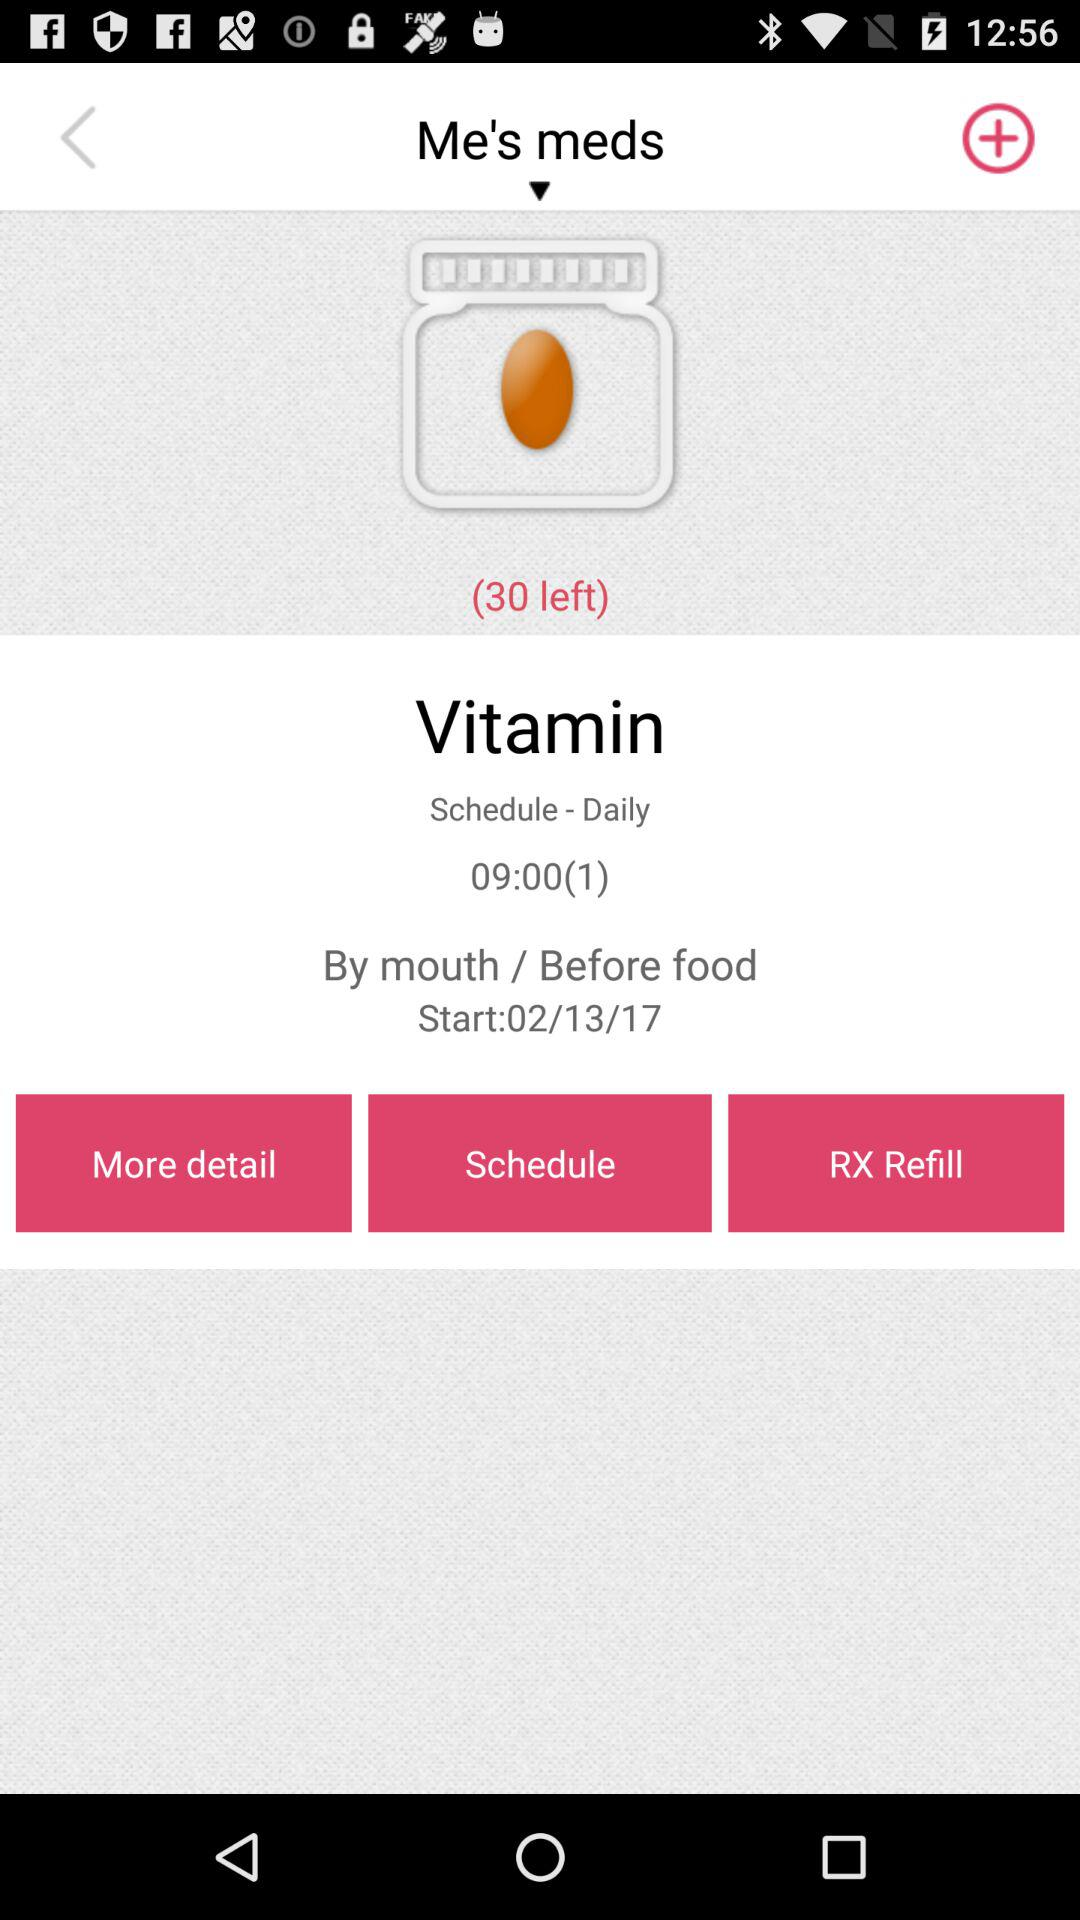What is the number of items left? The number of items left is 30. 